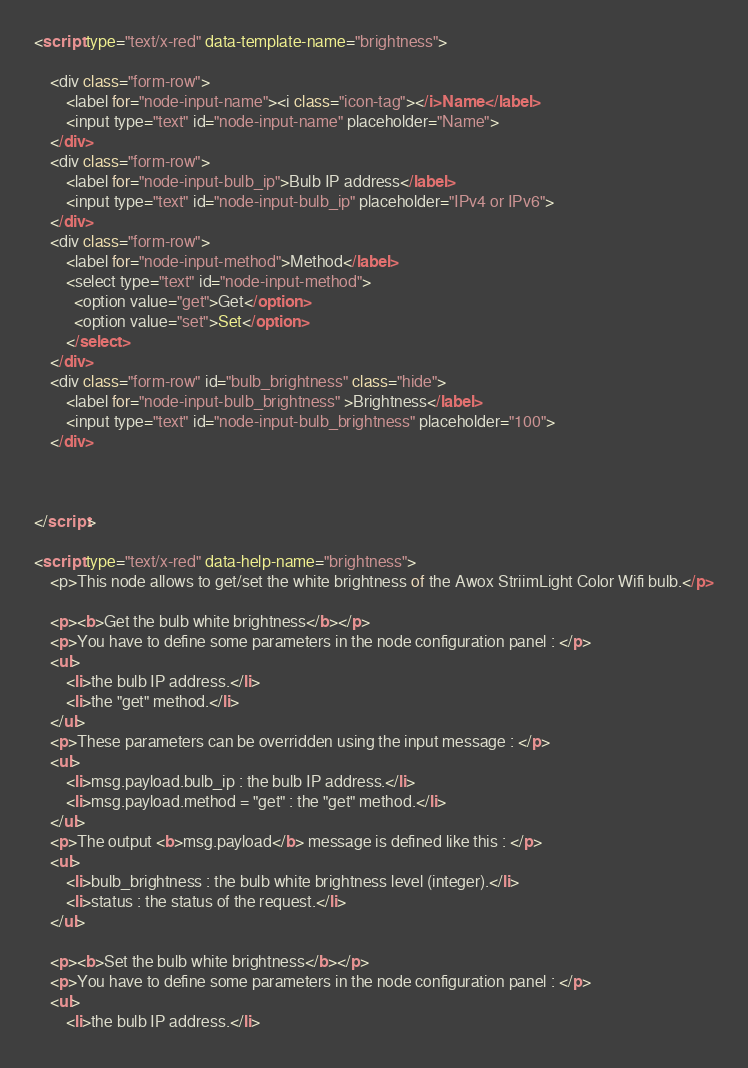Convert code to text. <code><loc_0><loc_0><loc_500><loc_500><_HTML_><script type="text/x-red" data-template-name="brightness">

    <div class="form-row">
        <label for="node-input-name"><i class="icon-tag"></i>Name</label>
        <input type="text" id="node-input-name" placeholder="Name">
    </div>
    <div class="form-row">
    	<label for="node-input-bulb_ip">Bulb IP address</label>
		<input type="text" id="node-input-bulb_ip" placeholder="IPv4 or IPv6">
  	</div>
  	<div class="form-row">
    	<label for="node-input-method">Method</label>
	    <select type="text" id="node-input-method">
	      <option value="get">Get</option>
	      <option value="set">Set</option>
	    </select>
  	</div>
  	<div class="form-row" id="bulb_brightness" class="hide">
    	<label for="node-input-bulb_brightness" >Brightness</label>
		<input type="text" id="node-input-bulb_brightness" placeholder="100">
  	</div>


  	
</script>

<script type="text/x-red" data-help-name="brightness">
    <p>This node allows to get/set the white brightness of the Awox StriimLight Color Wifi bulb.</p>
    
    <p><b>Get the bulb white brightness</b></p>
    <p>You have to define some parameters in the node configuration panel : </p>
	<ul>
        <li>the bulb IP address.</li>
        <li>the "get" method.</li>
    </ul>
    <p>These parameters can be overridden using the input message : </p>
	<ul>
        <li>msg.payload.bulb_ip : the bulb IP address.</li>
        <li>msg.payload.method = "get" : the "get" method.</li>
    </ul>
    <p>The output <b>msg.payload</b> message is defined like this : </p>
	<ul>
        <li>bulb_brightness : the bulb white brightness level (integer).</li>
        <li>status : the status of the request.</li>
    </ul>
    
    <p><b>Set the bulb white brightness</b></p>
    <p>You have to define some parameters in the node configuration panel : </p>
	<ul>
        <li>the bulb IP address.</li></code> 